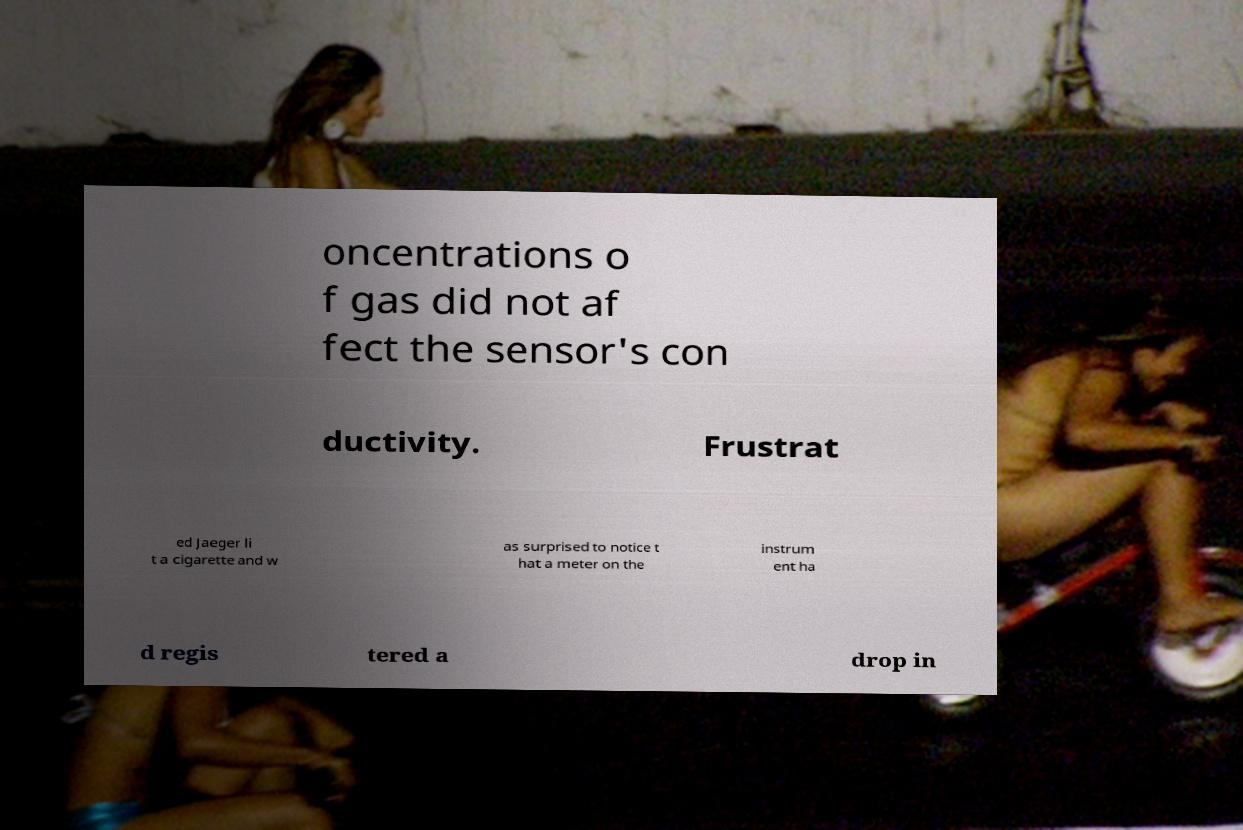What messages or text are displayed in this image? I need them in a readable, typed format. oncentrations o f gas did not af fect the sensor's con ductivity. Frustrat ed Jaeger li t a cigarette and w as surprised to notice t hat a meter on the instrum ent ha d regis tered a drop in 